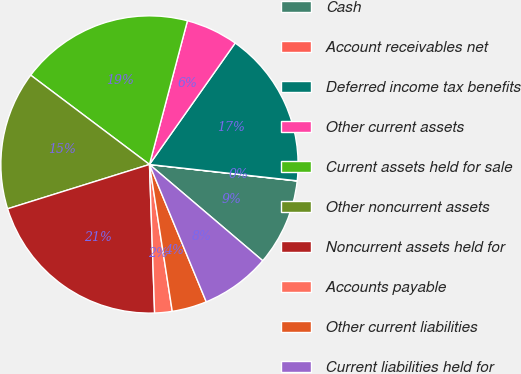Convert chart to OTSL. <chart><loc_0><loc_0><loc_500><loc_500><pie_chart><fcel>Cash<fcel>Account receivables net<fcel>Deferred income tax benefits<fcel>Other current assets<fcel>Current assets held for sale<fcel>Other noncurrent assets<fcel>Noncurrent assets held for<fcel>Accounts payable<fcel>Other current liabilities<fcel>Current liabilities held for<nl><fcel>9.44%<fcel>0.02%<fcel>16.97%<fcel>5.67%<fcel>18.85%<fcel>15.08%<fcel>20.73%<fcel>1.9%<fcel>3.79%<fcel>7.55%<nl></chart> 